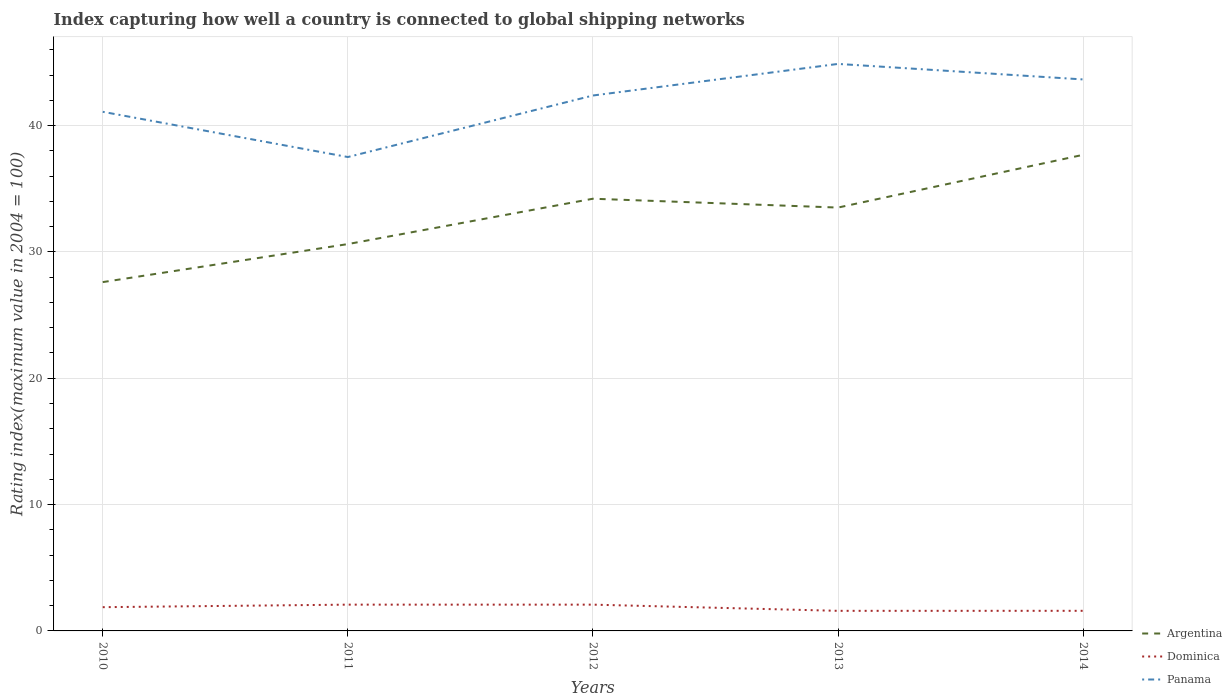Is the number of lines equal to the number of legend labels?
Provide a short and direct response. Yes. Across all years, what is the maximum rating index in Panama?
Offer a terse response. 37.51. In which year was the rating index in Argentina maximum?
Your answer should be compact. 2010. What is the total rating index in Panama in the graph?
Your response must be concise. 1.23. What is the difference between the highest and the second highest rating index in Panama?
Offer a terse response. 7.37. What is the difference between the highest and the lowest rating index in Panama?
Your answer should be very brief. 3. Is the rating index in Panama strictly greater than the rating index in Argentina over the years?
Offer a terse response. No. How many years are there in the graph?
Ensure brevity in your answer.  5. What is the difference between two consecutive major ticks on the Y-axis?
Offer a terse response. 10. Does the graph contain any zero values?
Your answer should be compact. No. Where does the legend appear in the graph?
Offer a very short reply. Bottom right. What is the title of the graph?
Provide a succinct answer. Index capturing how well a country is connected to global shipping networks. Does "Kiribati" appear as one of the legend labels in the graph?
Ensure brevity in your answer.  No. What is the label or title of the Y-axis?
Your answer should be very brief. Rating index(maximum value in 2004 = 100). What is the Rating index(maximum value in 2004 = 100) in Argentina in 2010?
Offer a terse response. 27.61. What is the Rating index(maximum value in 2004 = 100) in Dominica in 2010?
Your response must be concise. 1.88. What is the Rating index(maximum value in 2004 = 100) of Panama in 2010?
Your answer should be very brief. 41.09. What is the Rating index(maximum value in 2004 = 100) of Argentina in 2011?
Give a very brief answer. 30.62. What is the Rating index(maximum value in 2004 = 100) in Dominica in 2011?
Your answer should be very brief. 2.08. What is the Rating index(maximum value in 2004 = 100) of Panama in 2011?
Your response must be concise. 37.51. What is the Rating index(maximum value in 2004 = 100) in Argentina in 2012?
Give a very brief answer. 34.21. What is the Rating index(maximum value in 2004 = 100) of Dominica in 2012?
Ensure brevity in your answer.  2.08. What is the Rating index(maximum value in 2004 = 100) in Panama in 2012?
Your answer should be very brief. 42.38. What is the Rating index(maximum value in 2004 = 100) of Argentina in 2013?
Provide a short and direct response. 33.51. What is the Rating index(maximum value in 2004 = 100) in Dominica in 2013?
Offer a very short reply. 1.59. What is the Rating index(maximum value in 2004 = 100) of Panama in 2013?
Your response must be concise. 44.88. What is the Rating index(maximum value in 2004 = 100) of Argentina in 2014?
Keep it short and to the point. 37.69. What is the Rating index(maximum value in 2004 = 100) of Dominica in 2014?
Your answer should be compact. 1.59. What is the Rating index(maximum value in 2004 = 100) in Panama in 2014?
Your answer should be very brief. 43.65. Across all years, what is the maximum Rating index(maximum value in 2004 = 100) of Argentina?
Your answer should be compact. 37.69. Across all years, what is the maximum Rating index(maximum value in 2004 = 100) in Dominica?
Your response must be concise. 2.08. Across all years, what is the maximum Rating index(maximum value in 2004 = 100) in Panama?
Ensure brevity in your answer.  44.88. Across all years, what is the minimum Rating index(maximum value in 2004 = 100) in Argentina?
Offer a terse response. 27.61. Across all years, what is the minimum Rating index(maximum value in 2004 = 100) in Dominica?
Your response must be concise. 1.59. Across all years, what is the minimum Rating index(maximum value in 2004 = 100) of Panama?
Provide a succinct answer. 37.51. What is the total Rating index(maximum value in 2004 = 100) of Argentina in the graph?
Offer a very short reply. 163.64. What is the total Rating index(maximum value in 2004 = 100) of Dominica in the graph?
Your answer should be very brief. 9.22. What is the total Rating index(maximum value in 2004 = 100) in Panama in the graph?
Your answer should be compact. 209.51. What is the difference between the Rating index(maximum value in 2004 = 100) of Argentina in 2010 and that in 2011?
Provide a short and direct response. -3.01. What is the difference between the Rating index(maximum value in 2004 = 100) in Dominica in 2010 and that in 2011?
Give a very brief answer. -0.2. What is the difference between the Rating index(maximum value in 2004 = 100) in Panama in 2010 and that in 2011?
Provide a succinct answer. 3.58. What is the difference between the Rating index(maximum value in 2004 = 100) of Argentina in 2010 and that in 2012?
Your response must be concise. -6.6. What is the difference between the Rating index(maximum value in 2004 = 100) in Dominica in 2010 and that in 2012?
Ensure brevity in your answer.  -0.2. What is the difference between the Rating index(maximum value in 2004 = 100) of Panama in 2010 and that in 2012?
Provide a short and direct response. -1.29. What is the difference between the Rating index(maximum value in 2004 = 100) in Dominica in 2010 and that in 2013?
Provide a succinct answer. 0.29. What is the difference between the Rating index(maximum value in 2004 = 100) in Panama in 2010 and that in 2013?
Provide a succinct answer. -3.79. What is the difference between the Rating index(maximum value in 2004 = 100) of Argentina in 2010 and that in 2014?
Your answer should be compact. -10.08. What is the difference between the Rating index(maximum value in 2004 = 100) in Dominica in 2010 and that in 2014?
Your response must be concise. 0.29. What is the difference between the Rating index(maximum value in 2004 = 100) in Panama in 2010 and that in 2014?
Make the answer very short. -2.56. What is the difference between the Rating index(maximum value in 2004 = 100) of Argentina in 2011 and that in 2012?
Give a very brief answer. -3.59. What is the difference between the Rating index(maximum value in 2004 = 100) of Dominica in 2011 and that in 2012?
Your answer should be very brief. 0. What is the difference between the Rating index(maximum value in 2004 = 100) in Panama in 2011 and that in 2012?
Give a very brief answer. -4.87. What is the difference between the Rating index(maximum value in 2004 = 100) in Argentina in 2011 and that in 2013?
Make the answer very short. -2.89. What is the difference between the Rating index(maximum value in 2004 = 100) in Dominica in 2011 and that in 2013?
Offer a terse response. 0.49. What is the difference between the Rating index(maximum value in 2004 = 100) in Panama in 2011 and that in 2013?
Offer a very short reply. -7.37. What is the difference between the Rating index(maximum value in 2004 = 100) of Argentina in 2011 and that in 2014?
Provide a short and direct response. -7.07. What is the difference between the Rating index(maximum value in 2004 = 100) in Dominica in 2011 and that in 2014?
Offer a terse response. 0.49. What is the difference between the Rating index(maximum value in 2004 = 100) of Panama in 2011 and that in 2014?
Make the answer very short. -6.14. What is the difference between the Rating index(maximum value in 2004 = 100) in Dominica in 2012 and that in 2013?
Offer a terse response. 0.49. What is the difference between the Rating index(maximum value in 2004 = 100) in Argentina in 2012 and that in 2014?
Provide a succinct answer. -3.48. What is the difference between the Rating index(maximum value in 2004 = 100) of Dominica in 2012 and that in 2014?
Keep it short and to the point. 0.49. What is the difference between the Rating index(maximum value in 2004 = 100) in Panama in 2012 and that in 2014?
Keep it short and to the point. -1.27. What is the difference between the Rating index(maximum value in 2004 = 100) of Argentina in 2013 and that in 2014?
Provide a succinct answer. -4.18. What is the difference between the Rating index(maximum value in 2004 = 100) in Dominica in 2013 and that in 2014?
Provide a short and direct response. -0. What is the difference between the Rating index(maximum value in 2004 = 100) in Panama in 2013 and that in 2014?
Provide a short and direct response. 1.23. What is the difference between the Rating index(maximum value in 2004 = 100) of Argentina in 2010 and the Rating index(maximum value in 2004 = 100) of Dominica in 2011?
Ensure brevity in your answer.  25.53. What is the difference between the Rating index(maximum value in 2004 = 100) in Argentina in 2010 and the Rating index(maximum value in 2004 = 100) in Panama in 2011?
Give a very brief answer. -9.9. What is the difference between the Rating index(maximum value in 2004 = 100) of Dominica in 2010 and the Rating index(maximum value in 2004 = 100) of Panama in 2011?
Your response must be concise. -35.63. What is the difference between the Rating index(maximum value in 2004 = 100) in Argentina in 2010 and the Rating index(maximum value in 2004 = 100) in Dominica in 2012?
Provide a short and direct response. 25.53. What is the difference between the Rating index(maximum value in 2004 = 100) of Argentina in 2010 and the Rating index(maximum value in 2004 = 100) of Panama in 2012?
Provide a short and direct response. -14.77. What is the difference between the Rating index(maximum value in 2004 = 100) of Dominica in 2010 and the Rating index(maximum value in 2004 = 100) of Panama in 2012?
Offer a very short reply. -40.5. What is the difference between the Rating index(maximum value in 2004 = 100) of Argentina in 2010 and the Rating index(maximum value in 2004 = 100) of Dominica in 2013?
Ensure brevity in your answer.  26.02. What is the difference between the Rating index(maximum value in 2004 = 100) in Argentina in 2010 and the Rating index(maximum value in 2004 = 100) in Panama in 2013?
Your answer should be compact. -17.27. What is the difference between the Rating index(maximum value in 2004 = 100) of Dominica in 2010 and the Rating index(maximum value in 2004 = 100) of Panama in 2013?
Offer a terse response. -43. What is the difference between the Rating index(maximum value in 2004 = 100) of Argentina in 2010 and the Rating index(maximum value in 2004 = 100) of Dominica in 2014?
Offer a terse response. 26.02. What is the difference between the Rating index(maximum value in 2004 = 100) in Argentina in 2010 and the Rating index(maximum value in 2004 = 100) in Panama in 2014?
Offer a terse response. -16.04. What is the difference between the Rating index(maximum value in 2004 = 100) of Dominica in 2010 and the Rating index(maximum value in 2004 = 100) of Panama in 2014?
Give a very brief answer. -41.77. What is the difference between the Rating index(maximum value in 2004 = 100) in Argentina in 2011 and the Rating index(maximum value in 2004 = 100) in Dominica in 2012?
Keep it short and to the point. 28.54. What is the difference between the Rating index(maximum value in 2004 = 100) of Argentina in 2011 and the Rating index(maximum value in 2004 = 100) of Panama in 2012?
Make the answer very short. -11.76. What is the difference between the Rating index(maximum value in 2004 = 100) of Dominica in 2011 and the Rating index(maximum value in 2004 = 100) of Panama in 2012?
Provide a succinct answer. -40.3. What is the difference between the Rating index(maximum value in 2004 = 100) of Argentina in 2011 and the Rating index(maximum value in 2004 = 100) of Dominica in 2013?
Your answer should be compact. 29.03. What is the difference between the Rating index(maximum value in 2004 = 100) of Argentina in 2011 and the Rating index(maximum value in 2004 = 100) of Panama in 2013?
Your response must be concise. -14.26. What is the difference between the Rating index(maximum value in 2004 = 100) of Dominica in 2011 and the Rating index(maximum value in 2004 = 100) of Panama in 2013?
Offer a very short reply. -42.8. What is the difference between the Rating index(maximum value in 2004 = 100) in Argentina in 2011 and the Rating index(maximum value in 2004 = 100) in Dominica in 2014?
Keep it short and to the point. 29.03. What is the difference between the Rating index(maximum value in 2004 = 100) in Argentina in 2011 and the Rating index(maximum value in 2004 = 100) in Panama in 2014?
Offer a very short reply. -13.03. What is the difference between the Rating index(maximum value in 2004 = 100) in Dominica in 2011 and the Rating index(maximum value in 2004 = 100) in Panama in 2014?
Make the answer very short. -41.57. What is the difference between the Rating index(maximum value in 2004 = 100) of Argentina in 2012 and the Rating index(maximum value in 2004 = 100) of Dominica in 2013?
Keep it short and to the point. 32.62. What is the difference between the Rating index(maximum value in 2004 = 100) of Argentina in 2012 and the Rating index(maximum value in 2004 = 100) of Panama in 2013?
Provide a succinct answer. -10.67. What is the difference between the Rating index(maximum value in 2004 = 100) in Dominica in 2012 and the Rating index(maximum value in 2004 = 100) in Panama in 2013?
Offer a terse response. -42.8. What is the difference between the Rating index(maximum value in 2004 = 100) in Argentina in 2012 and the Rating index(maximum value in 2004 = 100) in Dominica in 2014?
Offer a very short reply. 32.62. What is the difference between the Rating index(maximum value in 2004 = 100) in Argentina in 2012 and the Rating index(maximum value in 2004 = 100) in Panama in 2014?
Your answer should be compact. -9.44. What is the difference between the Rating index(maximum value in 2004 = 100) in Dominica in 2012 and the Rating index(maximum value in 2004 = 100) in Panama in 2014?
Make the answer very short. -41.57. What is the difference between the Rating index(maximum value in 2004 = 100) of Argentina in 2013 and the Rating index(maximum value in 2004 = 100) of Dominica in 2014?
Your response must be concise. 31.92. What is the difference between the Rating index(maximum value in 2004 = 100) in Argentina in 2013 and the Rating index(maximum value in 2004 = 100) in Panama in 2014?
Offer a very short reply. -10.14. What is the difference between the Rating index(maximum value in 2004 = 100) in Dominica in 2013 and the Rating index(maximum value in 2004 = 100) in Panama in 2014?
Provide a short and direct response. -42.06. What is the average Rating index(maximum value in 2004 = 100) of Argentina per year?
Your answer should be compact. 32.73. What is the average Rating index(maximum value in 2004 = 100) of Dominica per year?
Keep it short and to the point. 1.84. What is the average Rating index(maximum value in 2004 = 100) in Panama per year?
Ensure brevity in your answer.  41.9. In the year 2010, what is the difference between the Rating index(maximum value in 2004 = 100) in Argentina and Rating index(maximum value in 2004 = 100) in Dominica?
Ensure brevity in your answer.  25.73. In the year 2010, what is the difference between the Rating index(maximum value in 2004 = 100) of Argentina and Rating index(maximum value in 2004 = 100) of Panama?
Provide a succinct answer. -13.48. In the year 2010, what is the difference between the Rating index(maximum value in 2004 = 100) of Dominica and Rating index(maximum value in 2004 = 100) of Panama?
Your answer should be very brief. -39.21. In the year 2011, what is the difference between the Rating index(maximum value in 2004 = 100) of Argentina and Rating index(maximum value in 2004 = 100) of Dominica?
Keep it short and to the point. 28.54. In the year 2011, what is the difference between the Rating index(maximum value in 2004 = 100) of Argentina and Rating index(maximum value in 2004 = 100) of Panama?
Keep it short and to the point. -6.89. In the year 2011, what is the difference between the Rating index(maximum value in 2004 = 100) in Dominica and Rating index(maximum value in 2004 = 100) in Panama?
Your response must be concise. -35.43. In the year 2012, what is the difference between the Rating index(maximum value in 2004 = 100) of Argentina and Rating index(maximum value in 2004 = 100) of Dominica?
Make the answer very short. 32.13. In the year 2012, what is the difference between the Rating index(maximum value in 2004 = 100) in Argentina and Rating index(maximum value in 2004 = 100) in Panama?
Your response must be concise. -8.17. In the year 2012, what is the difference between the Rating index(maximum value in 2004 = 100) of Dominica and Rating index(maximum value in 2004 = 100) of Panama?
Provide a short and direct response. -40.3. In the year 2013, what is the difference between the Rating index(maximum value in 2004 = 100) of Argentina and Rating index(maximum value in 2004 = 100) of Dominica?
Provide a succinct answer. 31.92. In the year 2013, what is the difference between the Rating index(maximum value in 2004 = 100) of Argentina and Rating index(maximum value in 2004 = 100) of Panama?
Offer a terse response. -11.37. In the year 2013, what is the difference between the Rating index(maximum value in 2004 = 100) in Dominica and Rating index(maximum value in 2004 = 100) in Panama?
Provide a succinct answer. -43.29. In the year 2014, what is the difference between the Rating index(maximum value in 2004 = 100) of Argentina and Rating index(maximum value in 2004 = 100) of Dominica?
Offer a terse response. 36.09. In the year 2014, what is the difference between the Rating index(maximum value in 2004 = 100) in Argentina and Rating index(maximum value in 2004 = 100) in Panama?
Your response must be concise. -5.97. In the year 2014, what is the difference between the Rating index(maximum value in 2004 = 100) of Dominica and Rating index(maximum value in 2004 = 100) of Panama?
Offer a very short reply. -42.06. What is the ratio of the Rating index(maximum value in 2004 = 100) of Argentina in 2010 to that in 2011?
Your answer should be compact. 0.9. What is the ratio of the Rating index(maximum value in 2004 = 100) of Dominica in 2010 to that in 2011?
Your response must be concise. 0.9. What is the ratio of the Rating index(maximum value in 2004 = 100) of Panama in 2010 to that in 2011?
Your answer should be compact. 1.1. What is the ratio of the Rating index(maximum value in 2004 = 100) of Argentina in 2010 to that in 2012?
Keep it short and to the point. 0.81. What is the ratio of the Rating index(maximum value in 2004 = 100) in Dominica in 2010 to that in 2012?
Keep it short and to the point. 0.9. What is the ratio of the Rating index(maximum value in 2004 = 100) of Panama in 2010 to that in 2012?
Make the answer very short. 0.97. What is the ratio of the Rating index(maximum value in 2004 = 100) of Argentina in 2010 to that in 2013?
Your answer should be very brief. 0.82. What is the ratio of the Rating index(maximum value in 2004 = 100) of Dominica in 2010 to that in 2013?
Offer a terse response. 1.18. What is the ratio of the Rating index(maximum value in 2004 = 100) in Panama in 2010 to that in 2013?
Give a very brief answer. 0.92. What is the ratio of the Rating index(maximum value in 2004 = 100) in Argentina in 2010 to that in 2014?
Provide a succinct answer. 0.73. What is the ratio of the Rating index(maximum value in 2004 = 100) of Dominica in 2010 to that in 2014?
Provide a succinct answer. 1.18. What is the ratio of the Rating index(maximum value in 2004 = 100) in Panama in 2010 to that in 2014?
Give a very brief answer. 0.94. What is the ratio of the Rating index(maximum value in 2004 = 100) of Argentina in 2011 to that in 2012?
Your answer should be compact. 0.9. What is the ratio of the Rating index(maximum value in 2004 = 100) of Dominica in 2011 to that in 2012?
Your answer should be very brief. 1. What is the ratio of the Rating index(maximum value in 2004 = 100) of Panama in 2011 to that in 2012?
Keep it short and to the point. 0.89. What is the ratio of the Rating index(maximum value in 2004 = 100) in Argentina in 2011 to that in 2013?
Provide a succinct answer. 0.91. What is the ratio of the Rating index(maximum value in 2004 = 100) in Dominica in 2011 to that in 2013?
Your response must be concise. 1.31. What is the ratio of the Rating index(maximum value in 2004 = 100) of Panama in 2011 to that in 2013?
Give a very brief answer. 0.84. What is the ratio of the Rating index(maximum value in 2004 = 100) of Argentina in 2011 to that in 2014?
Provide a succinct answer. 0.81. What is the ratio of the Rating index(maximum value in 2004 = 100) of Dominica in 2011 to that in 2014?
Your answer should be very brief. 1.31. What is the ratio of the Rating index(maximum value in 2004 = 100) in Panama in 2011 to that in 2014?
Keep it short and to the point. 0.86. What is the ratio of the Rating index(maximum value in 2004 = 100) of Argentina in 2012 to that in 2013?
Give a very brief answer. 1.02. What is the ratio of the Rating index(maximum value in 2004 = 100) of Dominica in 2012 to that in 2013?
Offer a terse response. 1.31. What is the ratio of the Rating index(maximum value in 2004 = 100) in Panama in 2012 to that in 2013?
Ensure brevity in your answer.  0.94. What is the ratio of the Rating index(maximum value in 2004 = 100) in Argentina in 2012 to that in 2014?
Give a very brief answer. 0.91. What is the ratio of the Rating index(maximum value in 2004 = 100) of Dominica in 2012 to that in 2014?
Your response must be concise. 1.31. What is the ratio of the Rating index(maximum value in 2004 = 100) of Panama in 2012 to that in 2014?
Your answer should be very brief. 0.97. What is the ratio of the Rating index(maximum value in 2004 = 100) of Argentina in 2013 to that in 2014?
Keep it short and to the point. 0.89. What is the ratio of the Rating index(maximum value in 2004 = 100) in Panama in 2013 to that in 2014?
Your response must be concise. 1.03. What is the difference between the highest and the second highest Rating index(maximum value in 2004 = 100) in Argentina?
Provide a short and direct response. 3.48. What is the difference between the highest and the second highest Rating index(maximum value in 2004 = 100) in Panama?
Provide a short and direct response. 1.23. What is the difference between the highest and the lowest Rating index(maximum value in 2004 = 100) in Argentina?
Your response must be concise. 10.08. What is the difference between the highest and the lowest Rating index(maximum value in 2004 = 100) in Dominica?
Give a very brief answer. 0.49. What is the difference between the highest and the lowest Rating index(maximum value in 2004 = 100) of Panama?
Offer a terse response. 7.37. 